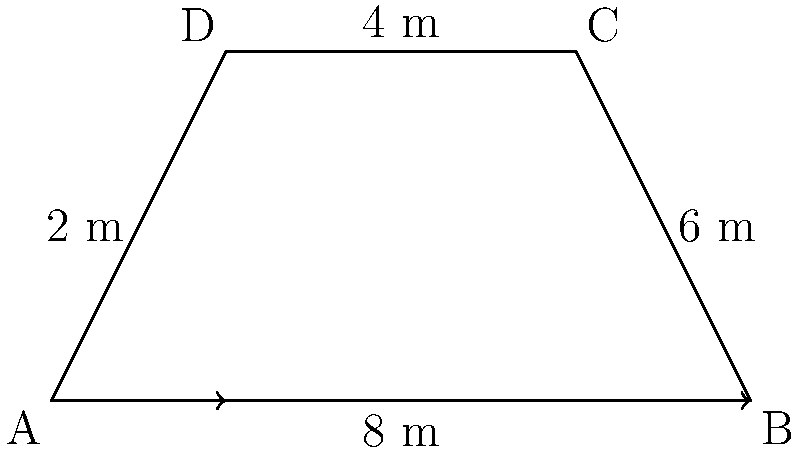Yo, check it! Your crew's about to throw down at the next breakdancing battle, and you need to calculate the area of this fresh trapezoid-shaped mat. The longer side (bottom) is 8 meters, the shorter side (top) is 6 meters, and the height is 4 meters. What's the total area of this fly breakdancing space in square meters? Alright, let's break this down step by step, homie:

1) We're dealing with a trapezoid here. The formula for the area of a trapezoid is:

   $$A = \frac{1}{2}(b_1 + b_2)h$$

   Where $A$ is the area, $b_1$ and $b_2$ are the lengths of the parallel sides, and $h$ is the height.

2) From the diagram, we can see:
   - The longer base (bottom) $b_1 = 8$ meters
   - The shorter base (top) $b_2 = 6$ meters
   - The height $h = 4$ meters

3) Now, let's plug these values into our formula:

   $$A = \frac{1}{2}(8 + 6) \times 4$$

4) First, add the bases:
   
   $$A = \frac{1}{2}(14) \times 4$$

5) Multiply:
   
   $$A = 7 \times 4 = 28$$

So, the total area of your breakdancing mat is 28 square meters. That's plenty of space for your crew to bust some sick moves!
Answer: 28 m² 